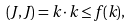<formula> <loc_0><loc_0><loc_500><loc_500>( { J } , { J } ) = { k } \cdot { k } \leq f ( { k } ) ,</formula> 